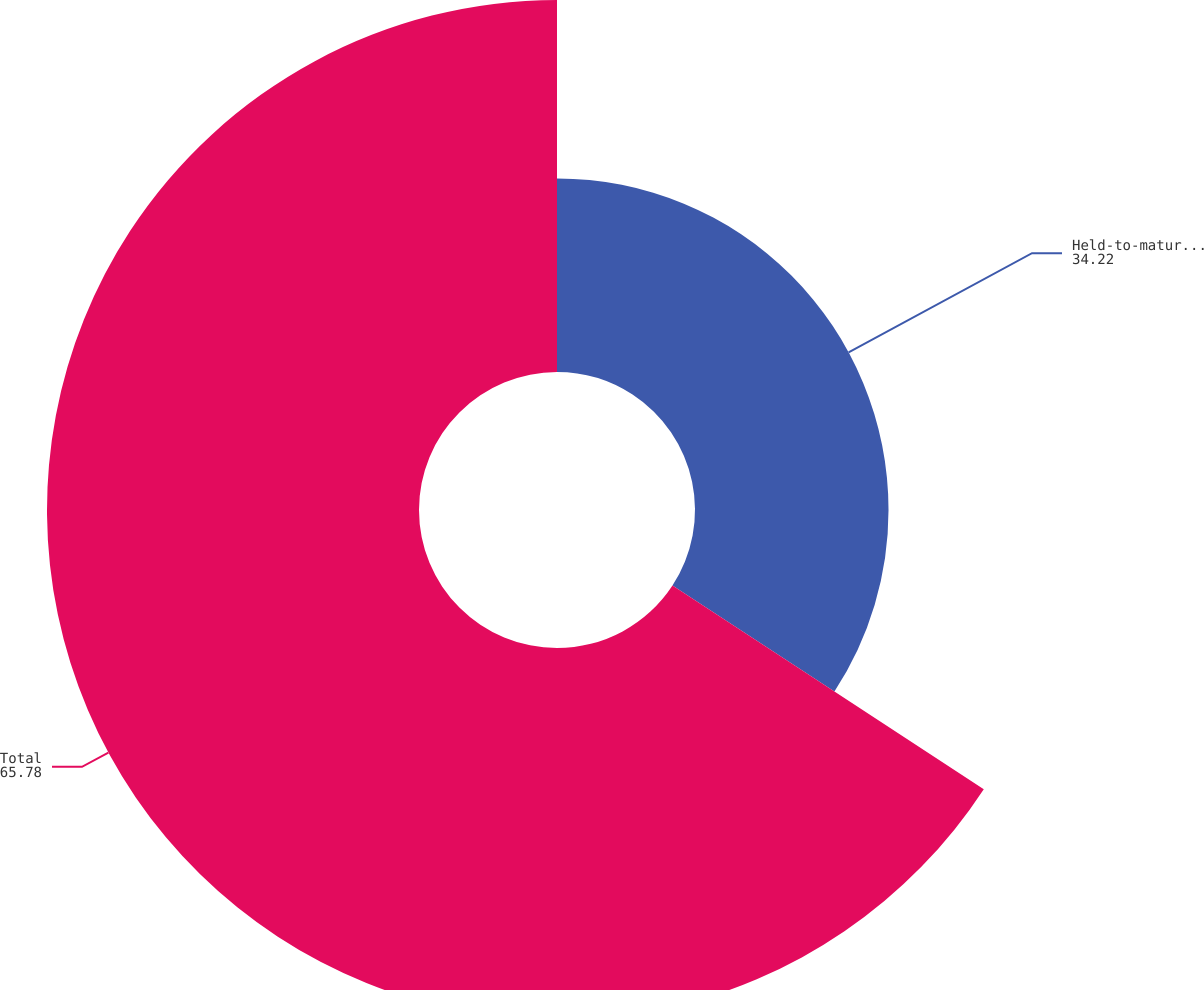<chart> <loc_0><loc_0><loc_500><loc_500><pie_chart><fcel>Held-to-maturity securities<fcel>Total<nl><fcel>34.22%<fcel>65.78%<nl></chart> 